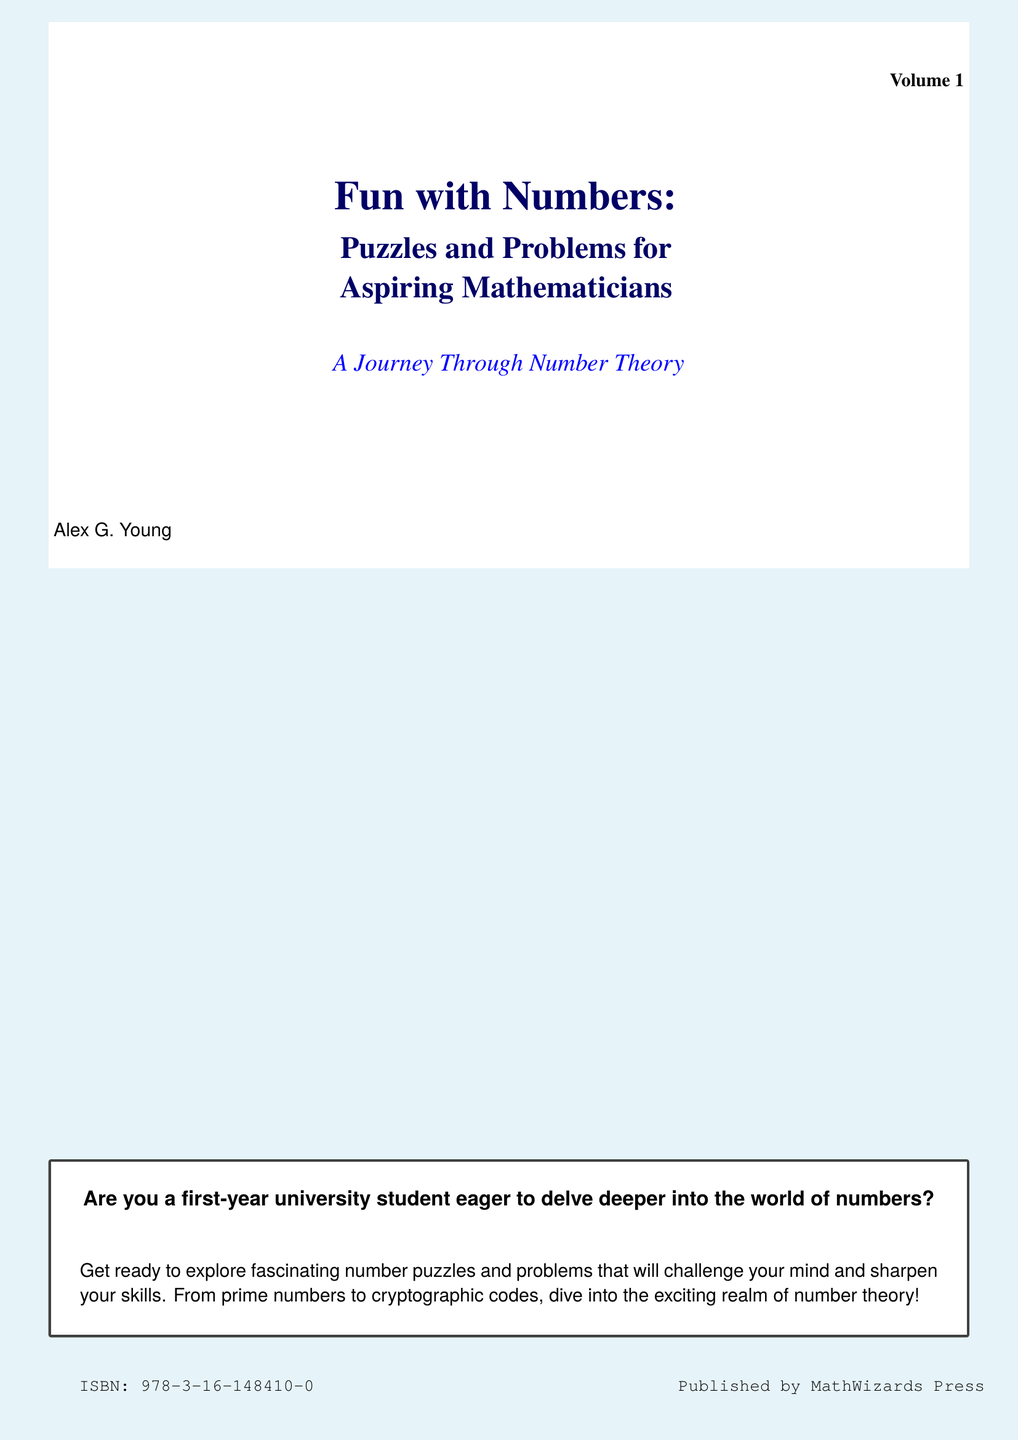What is the title of the book? The title is prominently displayed in a larger font on the cover.
Answer: Fun with Numbers: Puzzles and Problems for Aspiring Mathematicians Who is the author? The author's name is mentioned at the bottom of the cover.
Answer: Alex G. Young What is the ISBN number? The ISBN is listed in a smaller font on the bottom left of the cover.
Answer: 978-3-16-148410-0 What volume is this book? The volume number is indicated in the top right corner of the cover.
Answer: Volume 1 What is the primary focus of the book? The primary focus is indicated in the subtitle, expressing the intended audience and content.
Answer: Puzzles and Problems for Aspiring Mathematicians What color is the background of the cover? The background color is specified in the document description.
Answer: Light blue What type of problems does the book explore? The description in the tcolorbox provides insight into the types of problems included.
Answer: Number puzzles What is the publisher's name? The publisher's information is shown at the bottom right of the cover.
Answer: MathWizards Press What does the book aim to challenge? The tcolorbox text explains the purpose of the book regarding the reader's engagement.
Answer: Your mind 